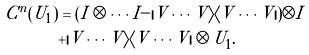Convert formula to latex. <formula><loc_0><loc_0><loc_500><loc_500>C ^ { n } ( U _ { 1 } ) & = ( I \otimes \cdots I - | V \cdots V \rangle \langle V \cdots V | ) \otimes I \\ & + | V \cdots V \rangle \langle V \cdots V | \otimes U _ { 1 } .</formula> 